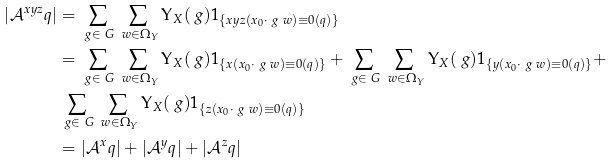<formula> <loc_0><loc_0><loc_500><loc_500>| \mathcal { A } ^ { x y z } _ { \ } q | & = \sum _ { \ g \in \ G } \sum _ { \ w \in \Omega _ { Y } } \Upsilon _ { X } ( \ g ) 1 _ { \{ x y z ( x _ { 0 } \cdot \ g \ w ) \equiv 0 ( q ) \} } \\ & = \sum _ { \ g \in \ G } \sum _ { \ w \in \Omega _ { Y } } \Upsilon _ { X } ( \ g ) 1 _ { \{ x ( x _ { 0 } \cdot \ g \ w ) \equiv 0 ( q ) \} } + \sum _ { \ g \in \ G } \sum _ { \ w \in \Omega _ { Y } } \Upsilon _ { X } ( \ g ) 1 _ { \{ y ( x _ { 0 } \cdot \ g \ w ) \equiv 0 ( q ) \} } + \\ & \sum _ { \ g \in \ G } \sum _ { \ w \in \Omega _ { Y } } \Upsilon _ { X } ( \ g ) 1 _ { \{ z ( x _ { 0 } \cdot \ g \ w ) \equiv 0 ( q ) \} } \\ & = | \mathcal { A } ^ { x } _ { \ } q | + | \mathcal { A } ^ { y } _ { \ } q | + | \mathcal { A } ^ { z } _ { \ } q | \\</formula> 